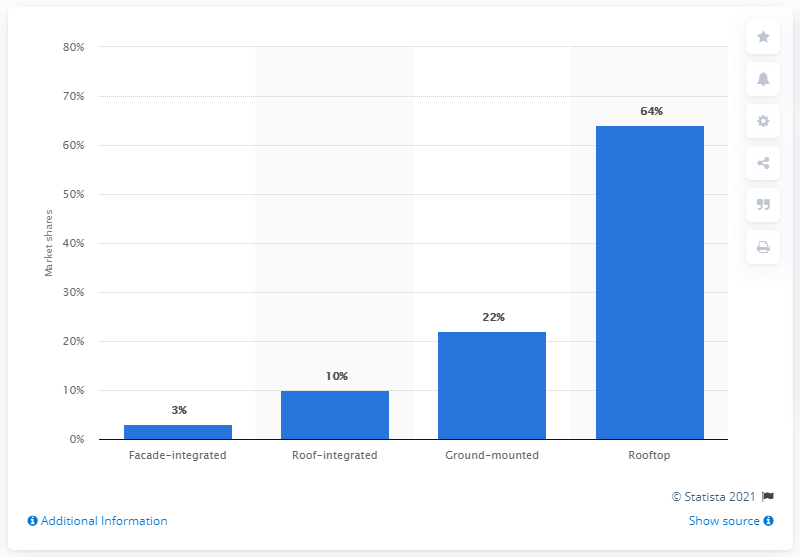Identify some key points in this picture. In 2008, the market share of ground-mounted photovoltaic (PV) installations was approximately 22%. 